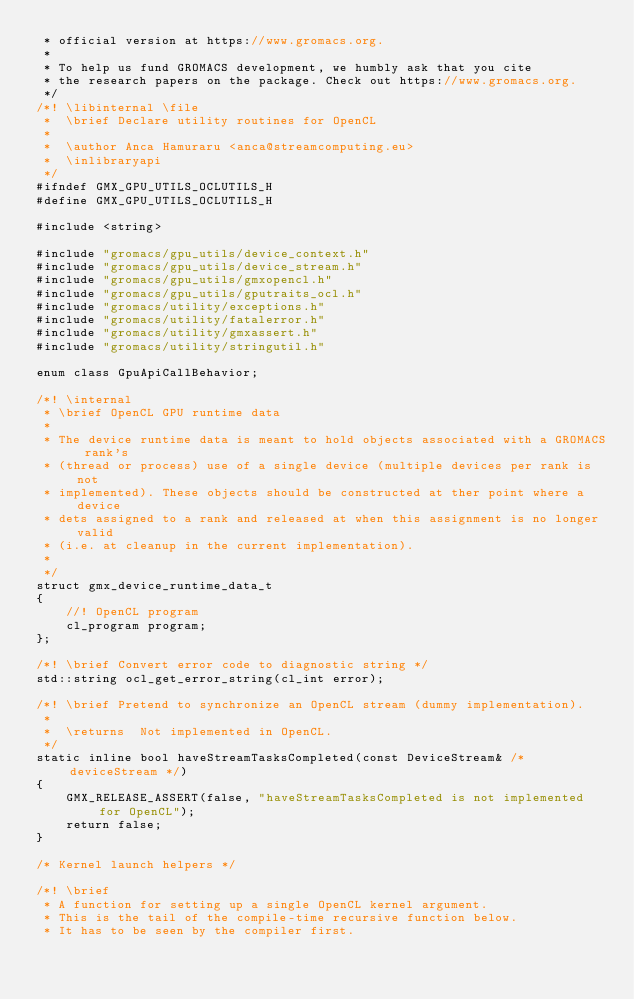Convert code to text. <code><loc_0><loc_0><loc_500><loc_500><_C_> * official version at https://www.gromacs.org.
 *
 * To help us fund GROMACS development, we humbly ask that you cite
 * the research papers on the package. Check out https://www.gromacs.org.
 */
/*! \libinternal \file
 *  \brief Declare utility routines for OpenCL
 *
 *  \author Anca Hamuraru <anca@streamcomputing.eu>
 *  \inlibraryapi
 */
#ifndef GMX_GPU_UTILS_OCLUTILS_H
#define GMX_GPU_UTILS_OCLUTILS_H

#include <string>

#include "gromacs/gpu_utils/device_context.h"
#include "gromacs/gpu_utils/device_stream.h"
#include "gromacs/gpu_utils/gmxopencl.h"
#include "gromacs/gpu_utils/gputraits_ocl.h"
#include "gromacs/utility/exceptions.h"
#include "gromacs/utility/fatalerror.h"
#include "gromacs/utility/gmxassert.h"
#include "gromacs/utility/stringutil.h"

enum class GpuApiCallBehavior;

/*! \internal
 * \brief OpenCL GPU runtime data
 *
 * The device runtime data is meant to hold objects associated with a GROMACS rank's
 * (thread or process) use of a single device (multiple devices per rank is not
 * implemented). These objects should be constructed at ther point where a device
 * dets assigned to a rank and released at when this assignment is no longer valid
 * (i.e. at cleanup in the current implementation).
 *
 */
struct gmx_device_runtime_data_t
{
    //! OpenCL program
    cl_program program;
};

/*! \brief Convert error code to diagnostic string */
std::string ocl_get_error_string(cl_int error);

/*! \brief Pretend to synchronize an OpenCL stream (dummy implementation).
 *
 *  \returns  Not implemented in OpenCL.
 */
static inline bool haveStreamTasksCompleted(const DeviceStream& /* deviceStream */)
{
    GMX_RELEASE_ASSERT(false, "haveStreamTasksCompleted is not implemented for OpenCL");
    return false;
}

/* Kernel launch helpers */

/*! \brief
 * A function for setting up a single OpenCL kernel argument.
 * This is the tail of the compile-time recursive function below.
 * It has to be seen by the compiler first.</code> 